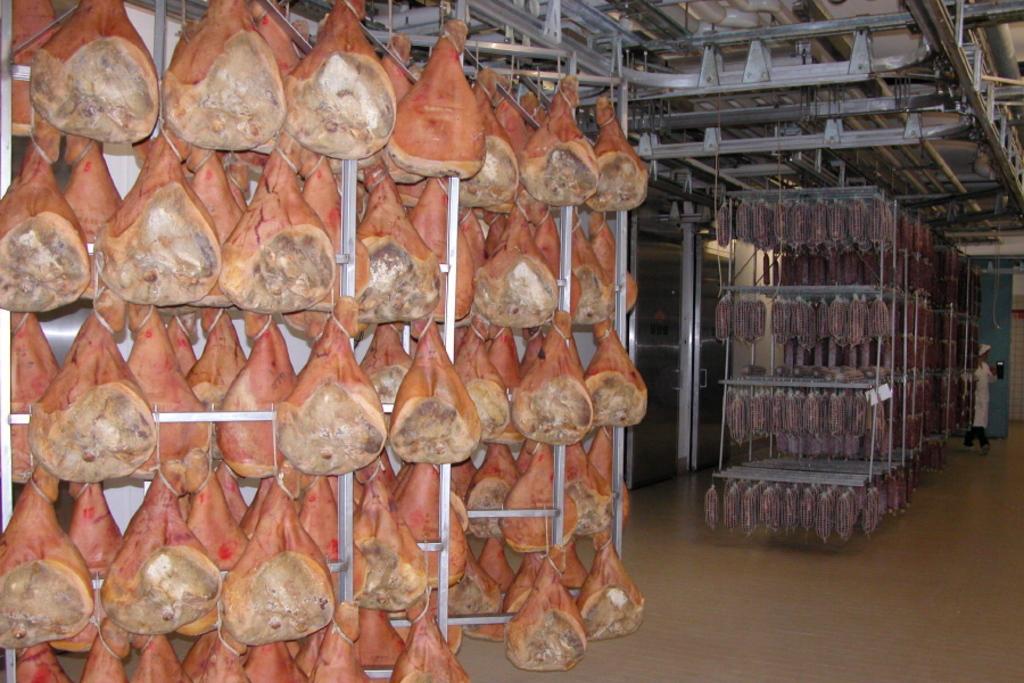Please provide a concise description of this image. In the picture we can see a hanger full of meat pieces and the hanger is fixed to the ceiling with some pipes and iron rods to it and we can see another hanger with some meat pieces and in the background we can see a person standing near the door. 